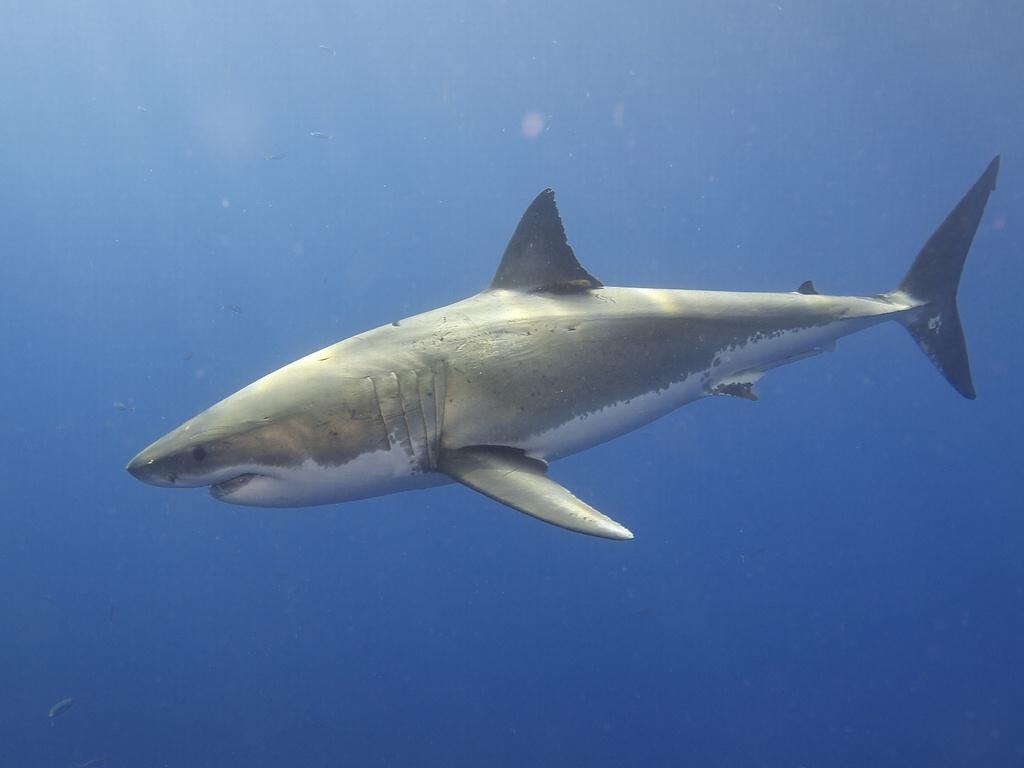What type of animal is in the image? There is a fish in the image. Where is the fish located? The fish is in the water. What type of farm can be seen in the image? There is no farm present in the image; it features a fish in the water. How many beds are visible in the image? There are no beds present in the image; it features a fish in the water. 